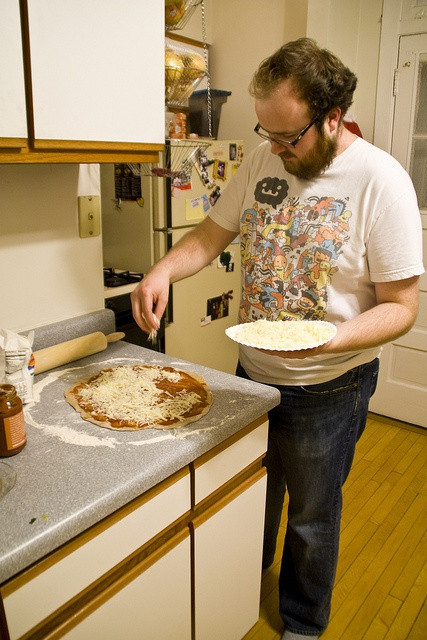Describe the objects in this image and their specific colors. I can see people in lightgray, black, tan, and olive tones, refrigerator in lightgray, tan, olive, and black tones, pizza in lightgray, tan, and olive tones, oven in lightgray, black, tan, and olive tones, and bottle in lightgray, maroon, olive, tan, and black tones in this image. 